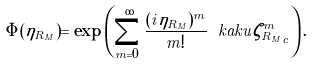<formula> <loc_0><loc_0><loc_500><loc_500>\Phi ( \eta _ { R _ { M } } ) = \exp \left ( \sum _ { m = 0 } ^ { \infty } \frac { ( i \eta _ { R _ { M } } ) ^ { m } } { m ! } \ k a k u { \zeta _ { R _ { M } } ^ { m } } _ { c } \right ) .</formula> 